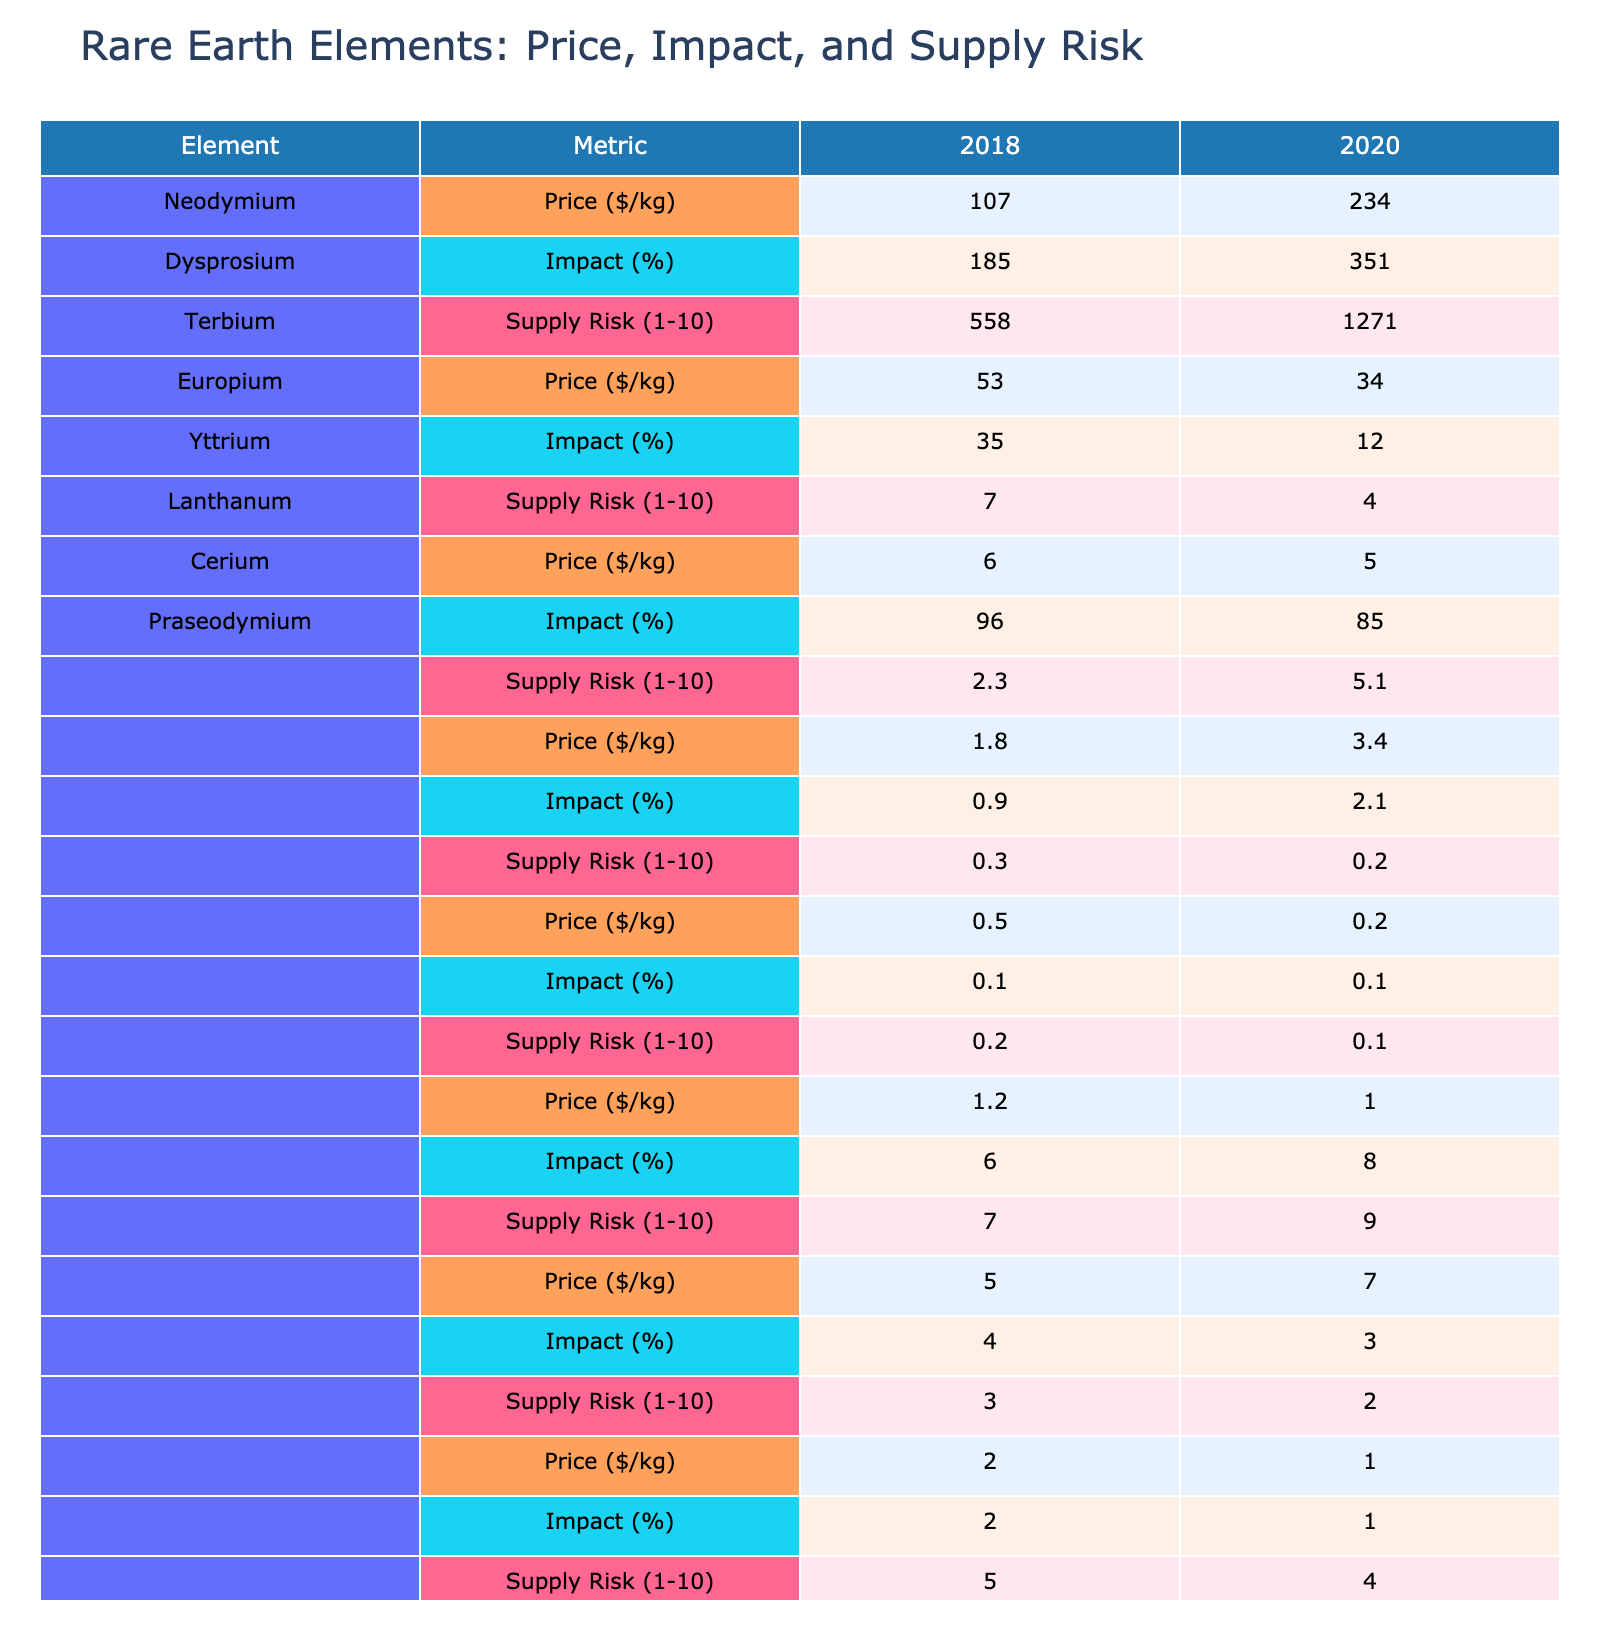What was the price of Neodymium in 2020? Referring to the table, Neodymium's price in 2020 is listed as $234/kg.
Answer: $234/kg Which rare earth element had the highest price in 2018? In the table for 2018, Terbium shows the highest price at $558/kg compared to other elements.
Answer: Terbium What is the average impact on electronics cost for all elements in 2020? The impact percentages for 2020 are: Neodymium (5.1%), Dysprosium (3.4%), Terbium (2.1%), Europium (0.2%), Yttrium (0.2%), Lanthanum (0.1%), Cerium (0.1%), and Praseodymium (1.0%). There are 8 values to average: (5.1 + 3.4 + 2.1 + 0.2 + 0.2 + 0.1 + 0.1 + 1.0) = 12.2%. The average is 12.2% / 8 = 1.525%.
Answer: 1.525% Which element saw the largest increase in price from 2018 to 2020? Comparing prices, Neodymium increased from $107 to $234 ($127 increase), and Dysprosium from $185 to $351 ($166 increase). Terbium also increased significantly from $558 to $1271 ($713 increase), which is the largest among them.
Answer: Terbium Is the supply risk for Europium in 2018 greater than for Yttrium in the same year? The supply risk for Europium in 2018 is rated at 4, while Yttrium has a supply risk of 3 for the same year. Since 4 is greater than 3, the statement is true.
Answer: Yes What was the percentage increase in the impact on electronics cost for Dysprosium from 2018 to 2020? The impact in 2018 was 1.8% and in 2020 it was 3.4%. The increase is 3.4% - 1.8% = 1.6%. To find the percentage increase, calculate (1.6 / 1.8) * 100 = 88.89%.
Answer: Approximately 88.89% Which element had the lowest supply risk in 2020? In 2020, Lanthanum had the lowest supply risk with a score of 1, which is lower than the other elements listed.
Answer: Lanthanum Does any element have a negative impact on electronics cost in 2020? The impacts listed for 2020 are all positive percentages: 5.1%, 3.4%, 2.1%, 0.2%, 0.2%, 0.1%, 0.1%, and 1.0%. Therefore, no element has a negative impact.
Answer: No What is the difference between the highest and lowest prices among the elements in 2020? The highest price in 2020 is Terbium at $1271/kg, and the lowest is Europium at $34/kg. The difference is $1271 - $34 = $1237.
Answer: $1237 Which two elements both had a price decrease from 2018 to 2020? Europium dropped from $53/kg to $34/kg and Lanthanum dropped from $7/kg to $4/kg, indicating decreases for both.
Answer: Europium and Lanthanum 